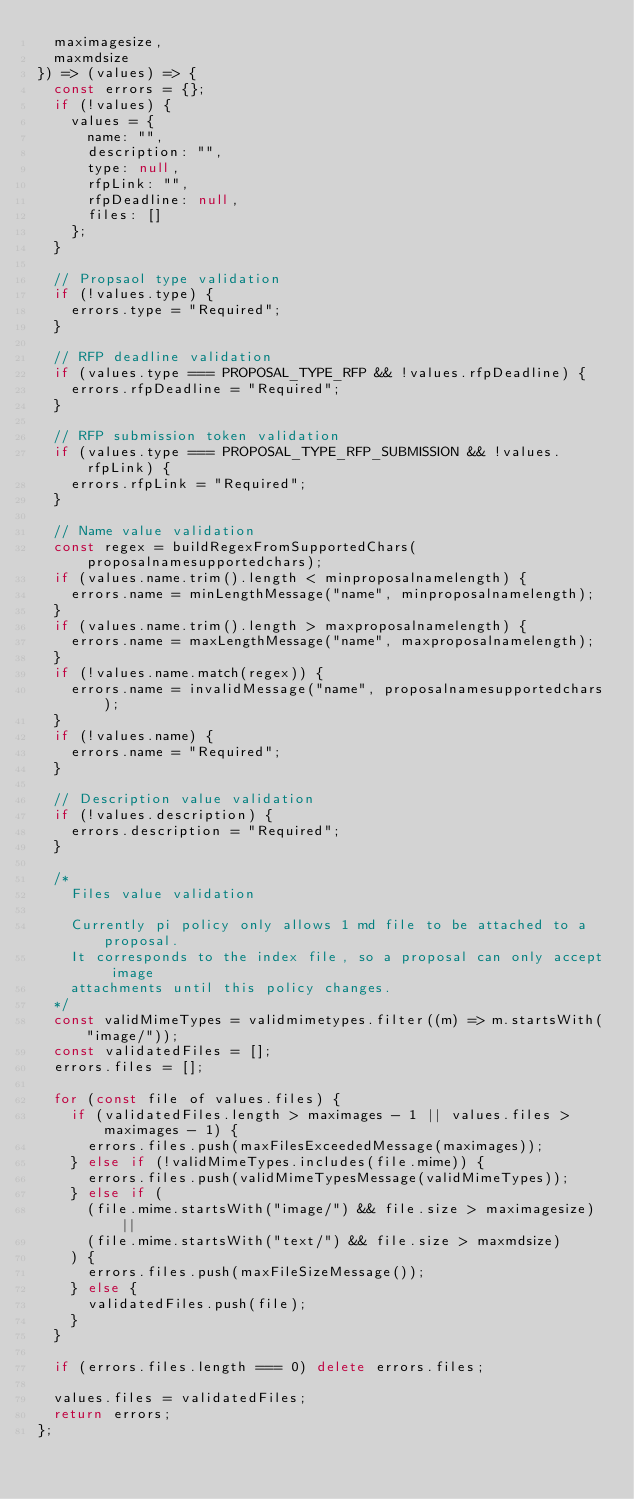Convert code to text. <code><loc_0><loc_0><loc_500><loc_500><_JavaScript_>  maximagesize,
  maxmdsize
}) => (values) => {
  const errors = {};
  if (!values) {
    values = {
      name: "",
      description: "",
      type: null,
      rfpLink: "",
      rfpDeadline: null,
      files: []
    };
  }

  // Propsaol type validation
  if (!values.type) {
    errors.type = "Required";
  }

  // RFP deadline validation
  if (values.type === PROPOSAL_TYPE_RFP && !values.rfpDeadline) {
    errors.rfpDeadline = "Required";
  }

  // RFP submission token validation
  if (values.type === PROPOSAL_TYPE_RFP_SUBMISSION && !values.rfpLink) {
    errors.rfpLink = "Required";
  }

  // Name value validation
  const regex = buildRegexFromSupportedChars(proposalnamesupportedchars);
  if (values.name.trim().length < minproposalnamelength) {
    errors.name = minLengthMessage("name", minproposalnamelength);
  }
  if (values.name.trim().length > maxproposalnamelength) {
    errors.name = maxLengthMessage("name", maxproposalnamelength);
  }
  if (!values.name.match(regex)) {
    errors.name = invalidMessage("name", proposalnamesupportedchars);
  }
  if (!values.name) {
    errors.name = "Required";
  }

  // Description value validation
  if (!values.description) {
    errors.description = "Required";
  }

  /*
    Files value validation

    Currently pi policy only allows 1 md file to be attached to a proposal.
    It corresponds to the index file, so a proposal can only accept image
    attachments until this policy changes.
  */
  const validMimeTypes = validmimetypes.filter((m) => m.startsWith("image/"));
  const validatedFiles = [];
  errors.files = [];

  for (const file of values.files) {
    if (validatedFiles.length > maximages - 1 || values.files > maximages - 1) {
      errors.files.push(maxFilesExceededMessage(maximages));
    } else if (!validMimeTypes.includes(file.mime)) {
      errors.files.push(validMimeTypesMessage(validMimeTypes));
    } else if (
      (file.mime.startsWith("image/") && file.size > maximagesize) ||
      (file.mime.startsWith("text/") && file.size > maxmdsize)
    ) {
      errors.files.push(maxFileSizeMessage());
    } else {
      validatedFiles.push(file);
    }
  }

  if (errors.files.length === 0) delete errors.files;

  values.files = validatedFiles;
  return errors;
};
</code> 